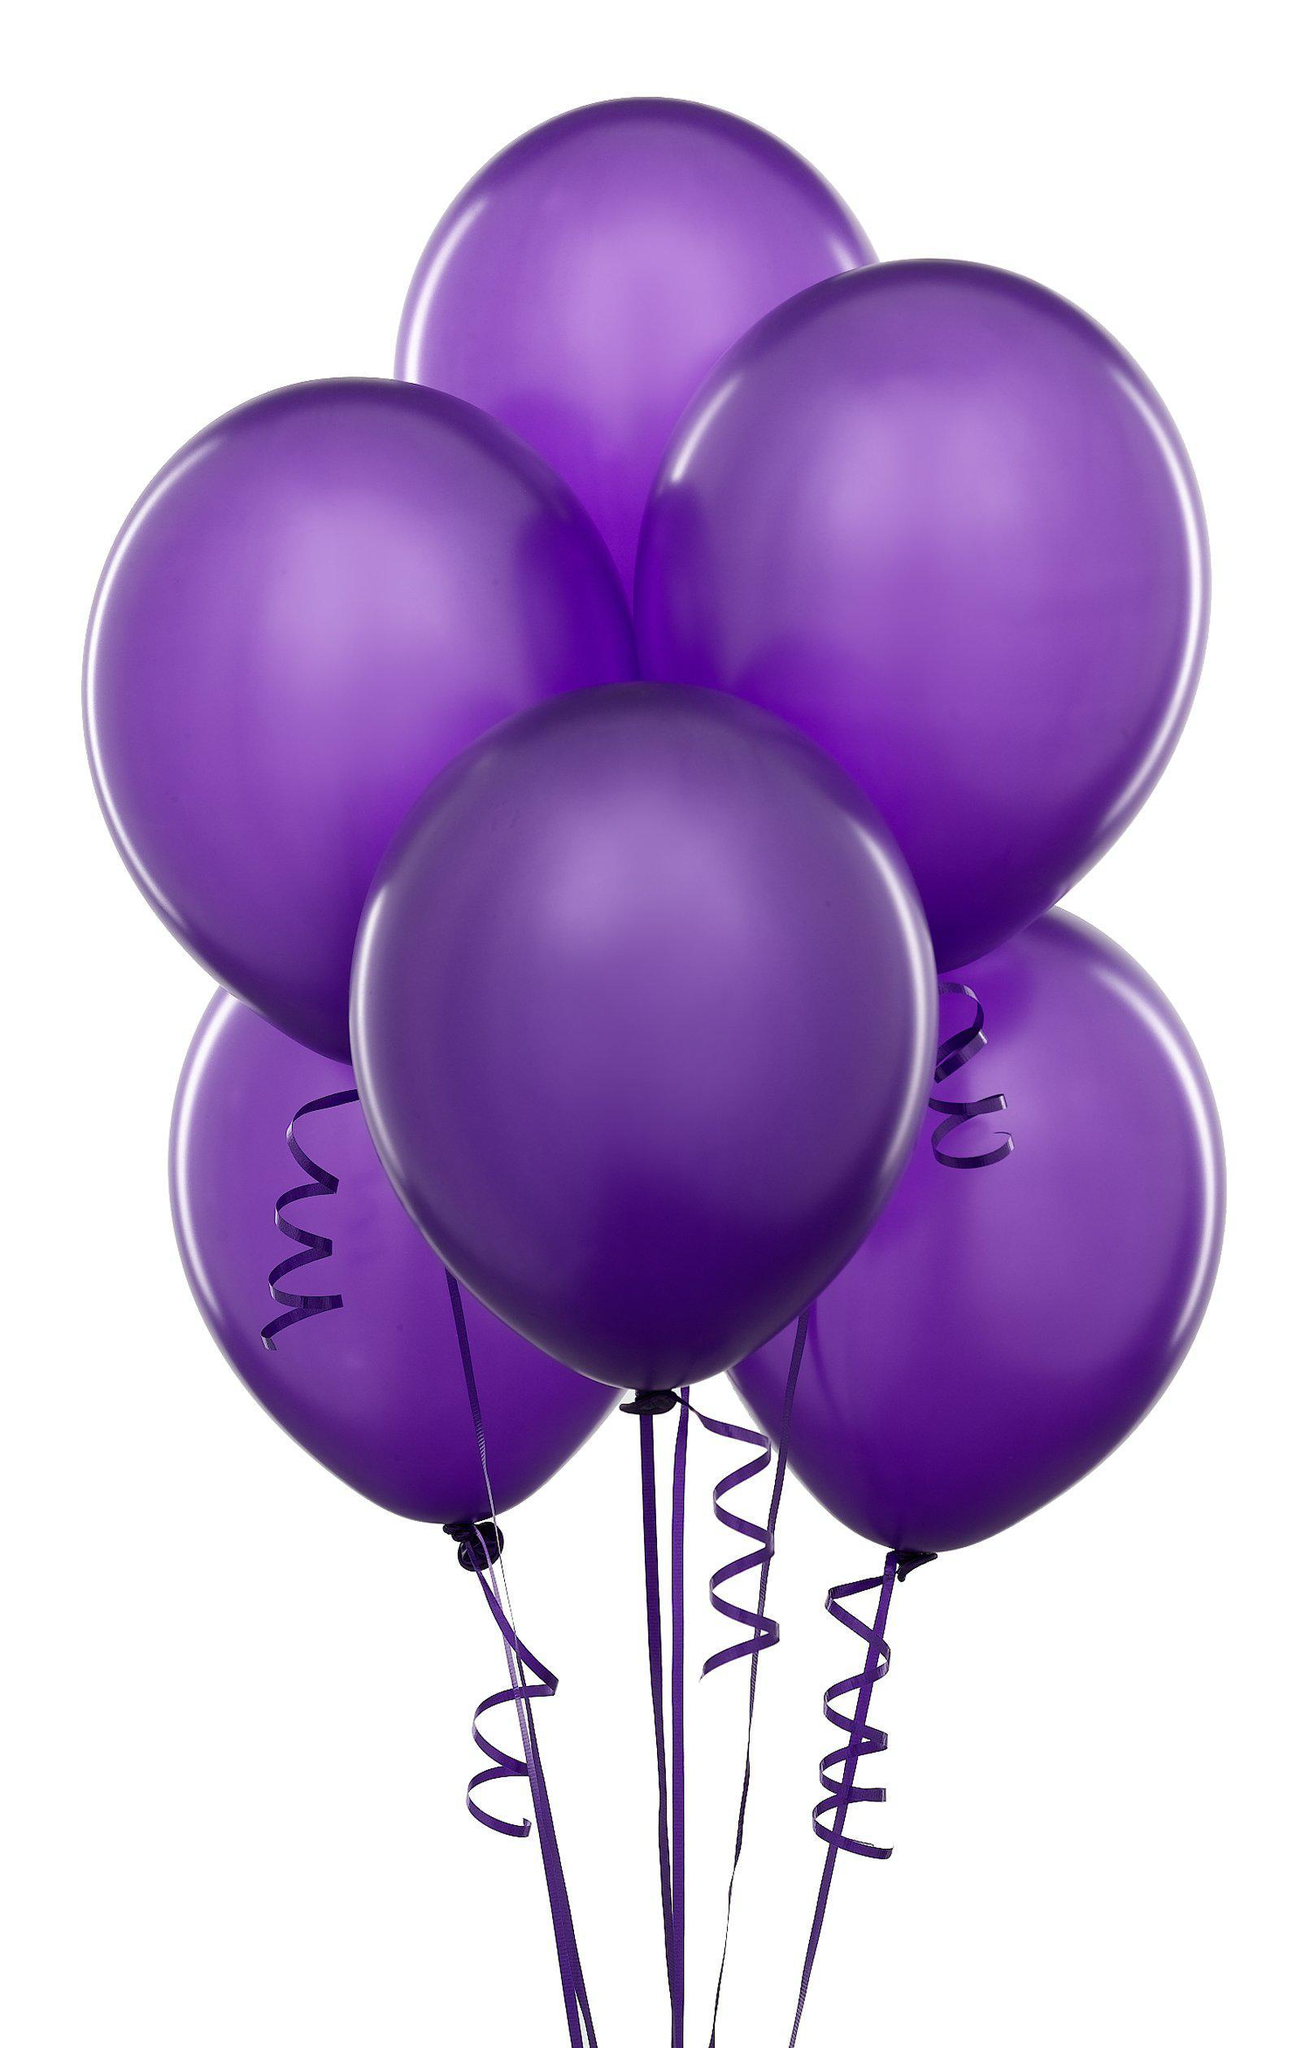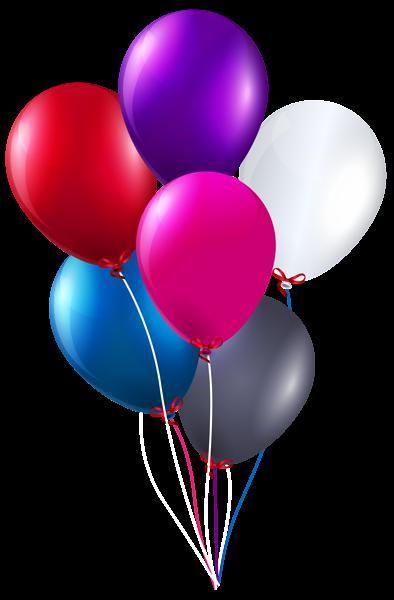The first image is the image on the left, the second image is the image on the right. Given the left and right images, does the statement "An image shows exactly three overlapping balloons, and one of the balloons is yellow." hold true? Answer yes or no. No. The first image is the image on the left, the second image is the image on the right. Considering the images on both sides, is "In one image, there is one blue balloon, one yellow balloon, and one purple balloon side by side" valid? Answer yes or no. No. 